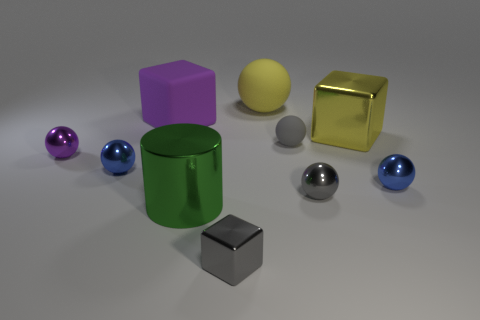Is the number of big matte things in front of the small gray rubber object greater than the number of gray shiny spheres? no 